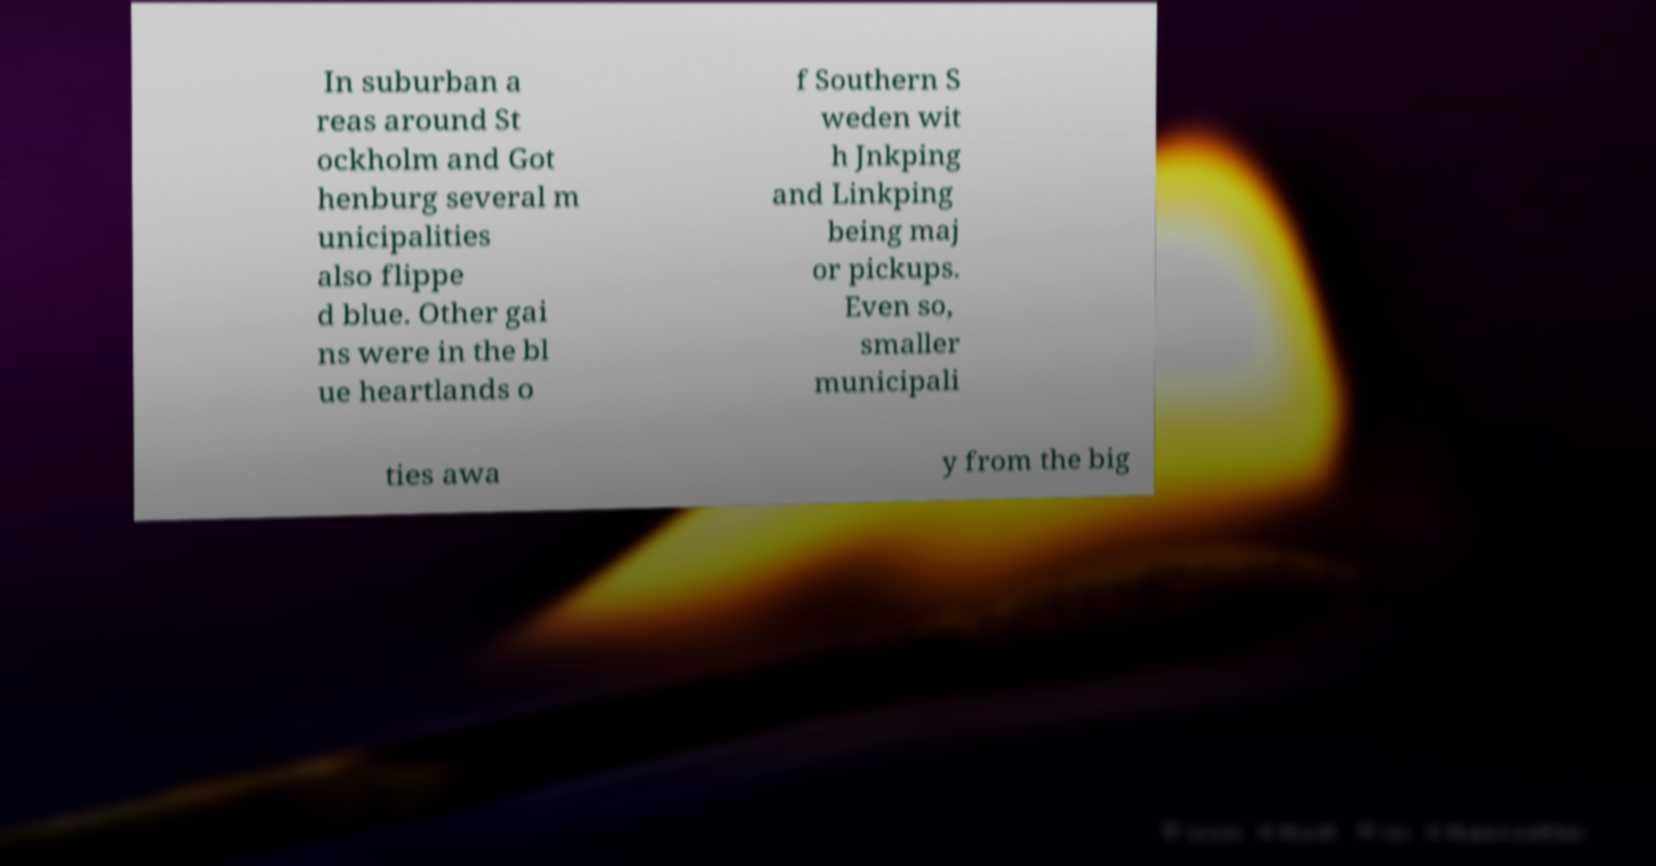Could you assist in decoding the text presented in this image and type it out clearly? In suburban a reas around St ockholm and Got henburg several m unicipalities also flippe d blue. Other gai ns were in the bl ue heartlands o f Southern S weden wit h Jnkping and Linkping being maj or pickups. Even so, smaller municipali ties awa y from the big 